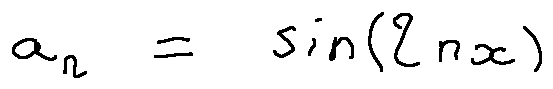Convert formula to latex. <formula><loc_0><loc_0><loc_500><loc_500>a _ { n } = \sin ( 2 n x )</formula> 